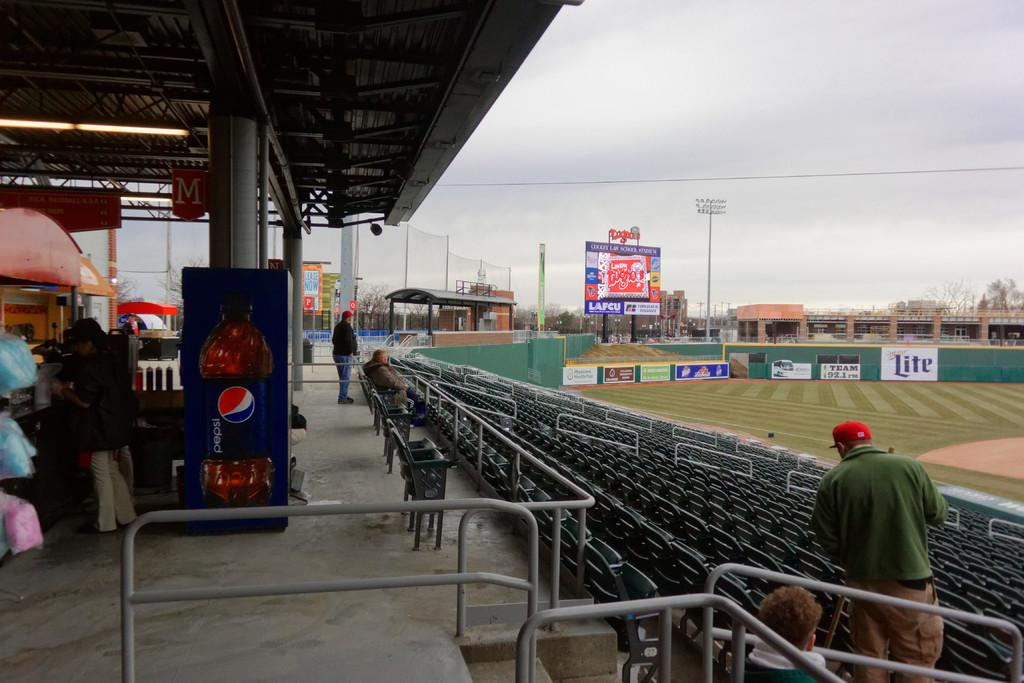Provide a one-sentence caption for the provided image. A pepsi machine at the top of a set of stadium bleachers. 